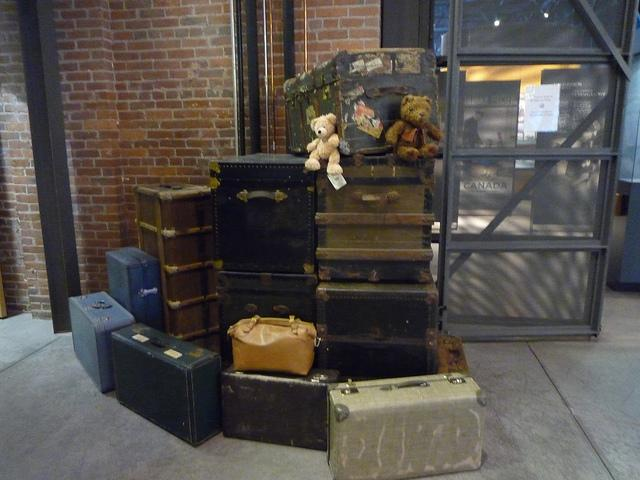What business is this display promoting?

Choices:
A) nature trips
B) restaurant
C) travel agency
D) sporting goods travel agency 